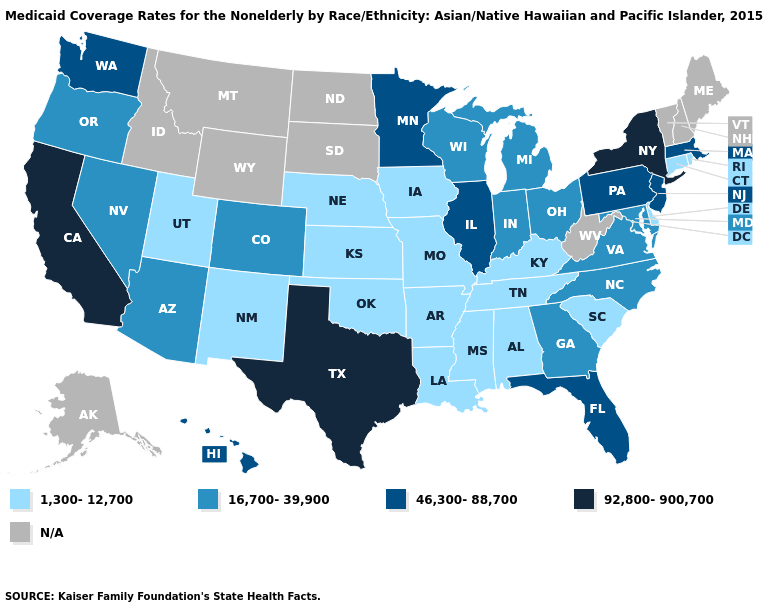What is the lowest value in the MidWest?
Quick response, please. 1,300-12,700. Does Oregon have the highest value in the USA?
Give a very brief answer. No. Does the first symbol in the legend represent the smallest category?
Concise answer only. Yes. Name the states that have a value in the range N/A?
Write a very short answer. Alaska, Idaho, Maine, Montana, New Hampshire, North Dakota, South Dakota, Vermont, West Virginia, Wyoming. What is the highest value in the USA?
Short answer required. 92,800-900,700. What is the highest value in the West ?
Keep it brief. 92,800-900,700. Does the first symbol in the legend represent the smallest category?
Concise answer only. Yes. Does the map have missing data?
Be succinct. Yes. Name the states that have a value in the range 46,300-88,700?
Give a very brief answer. Florida, Hawaii, Illinois, Massachusetts, Minnesota, New Jersey, Pennsylvania, Washington. What is the highest value in the USA?
Quick response, please. 92,800-900,700. Does Delaware have the highest value in the South?
Keep it brief. No. Among the states that border Arizona , which have the highest value?
Short answer required. California. What is the highest value in states that border New Hampshire?
Be succinct. 46,300-88,700. What is the value of Alaska?
Be succinct. N/A. What is the lowest value in the USA?
Write a very short answer. 1,300-12,700. 